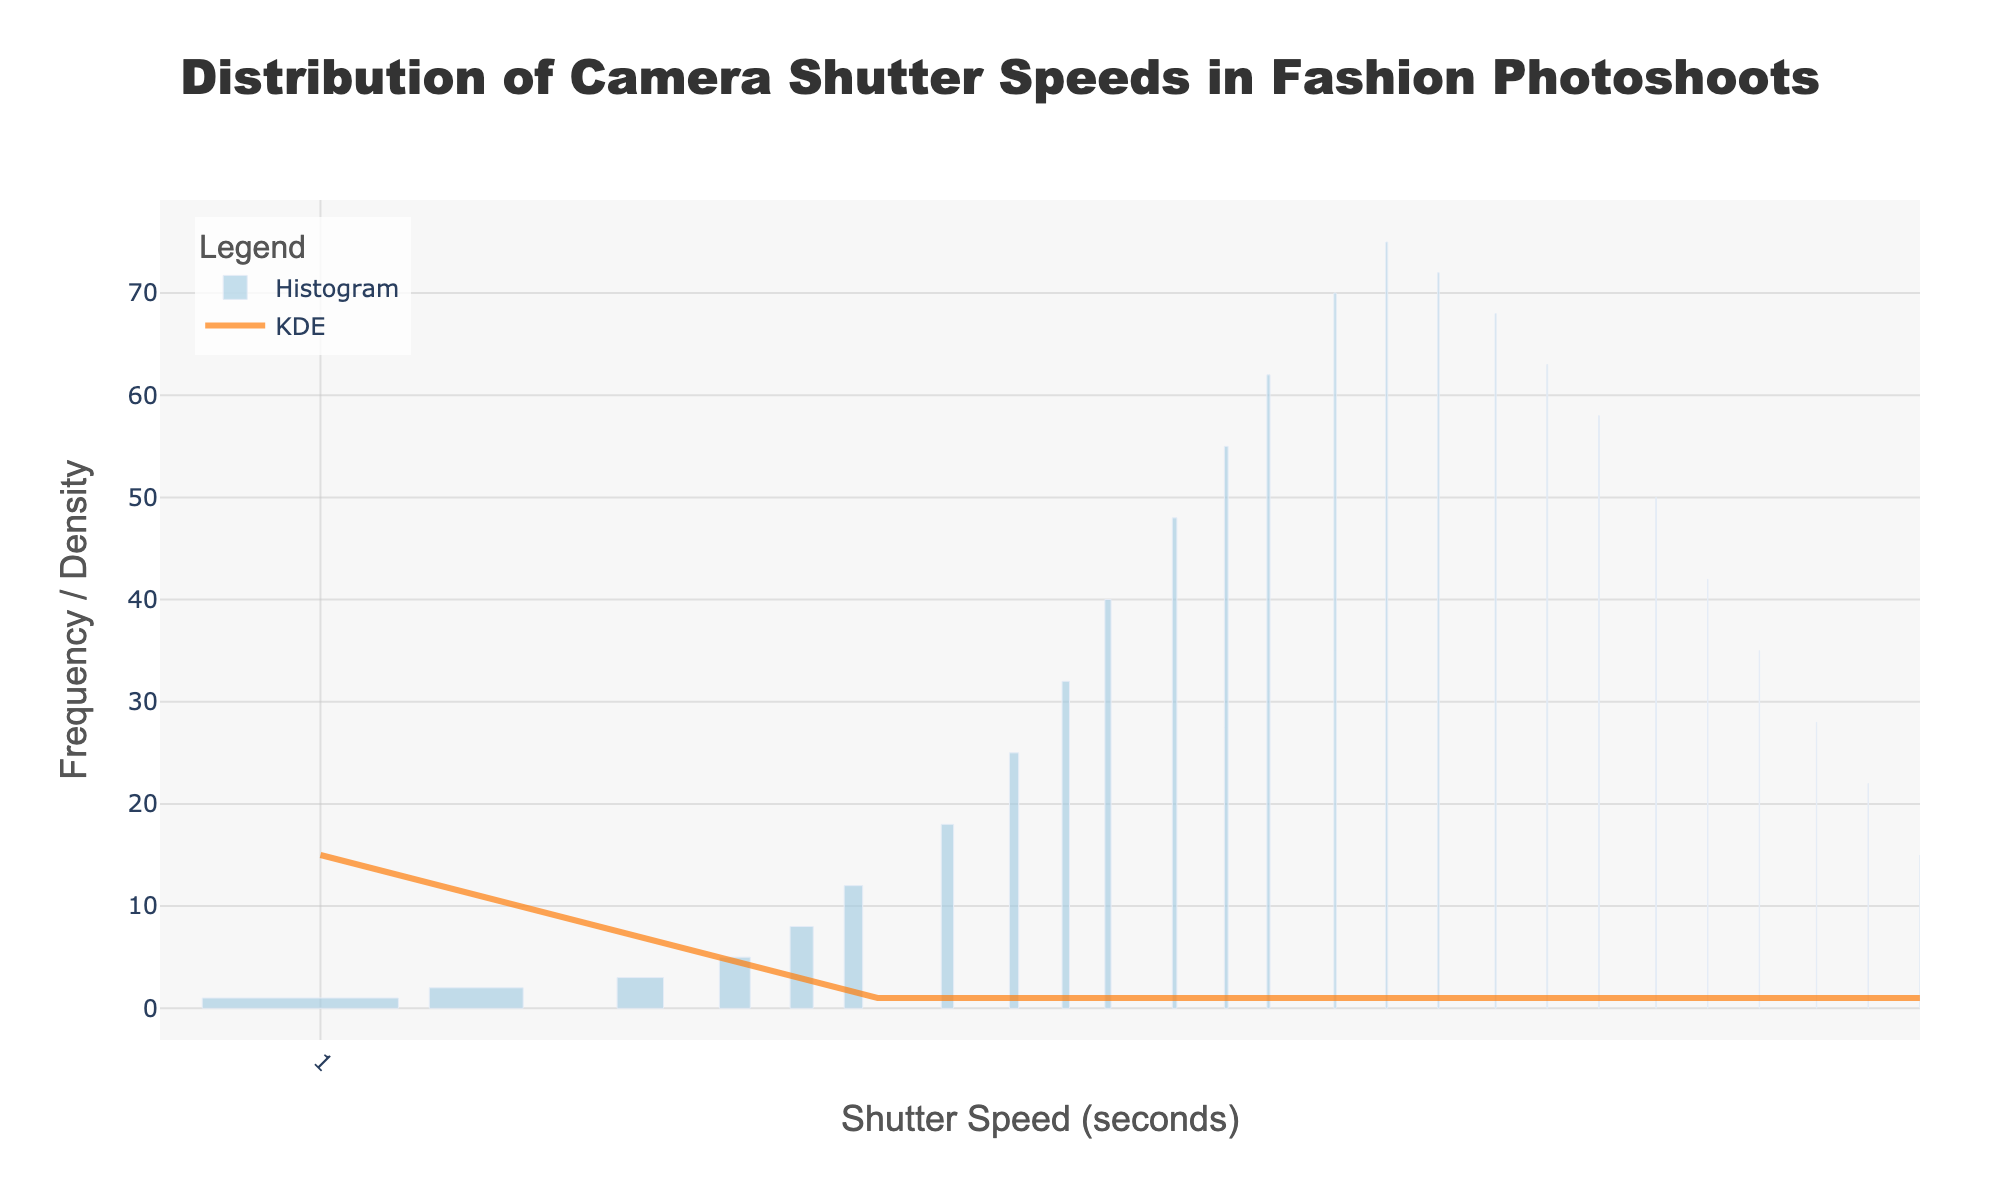What is the title of the figure? The title is displayed prominently at the top of the figure, stating the main topic of the visualization.
Answer: Distribution of Camera Shutter Speeds in Fashion Photoshoots What does the x-axis represent? The x-axis is labeled to describe what it measures, which in this case is the shutter speed in seconds.
Answer: Shutter Speed (seconds) How many shutter speeds are plotted in the histogram? Count the number of unique shutter speed data points along the x-axis.
Answer: 24 What is the most frequently used shutter speed? Look for the highest bar in the histogram and note the corresponding shutter speed below it.
Answer: 1/100 (75 times) How does the frequency change as the shutter speed increases from 1/1000 to 1/100? Observe the height of the bars from 1/1000 to 1/100 and describe the trend.
Answer: The frequency generally increases What is the trend of the KDE curve relative to the histogram bars? The KDE curve provides a smoothed estimate of the distribution. Compare the curve height with the bar heights as the shutter speed changes.
Answer: The KDE curve follows the histogram closely but smooths out individual bar variations Which shutter speed has the lowest usage frequency? Identify the bar with the least height and check the corresponding shutter speed.
Answer: 1 second (1 time) At what shutter speed does the histogram have the steepest decline? Find where the frequency sharply drops when viewing from fastest to slowest shutter speeds.
Answer: Between 1/80 and 1/100 When comparing shutter speeds of 1/200 and 1/60, which one is more frequently used according to the histogram? Compare the heights of the bars at 1/200 and 1/60.
Answer: 1/60 Estimate the frequency of usage for the shutter speed 1/30 based on the KDE curve. Observe the KDE curve at the point corresponding to 1/30 shutter speed.
Answer: Approximately 40 